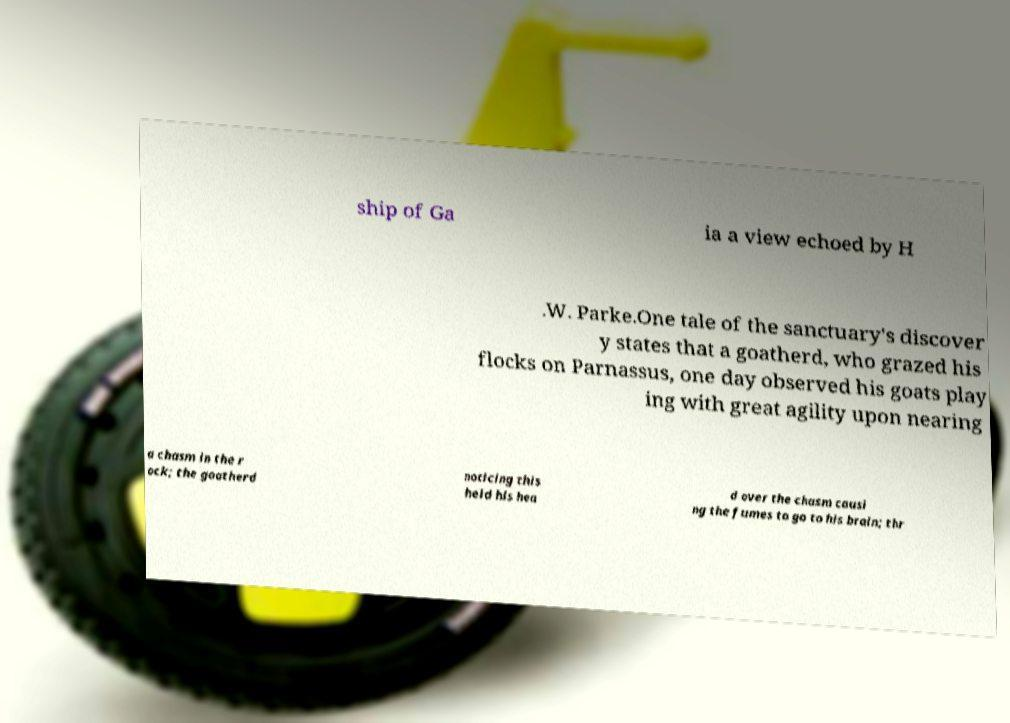For documentation purposes, I need the text within this image transcribed. Could you provide that? ship of Ga ia a view echoed by H .W. Parke.One tale of the sanctuary's discover y states that a goatherd, who grazed his flocks on Parnassus, one day observed his goats play ing with great agility upon nearing a chasm in the r ock; the goatherd noticing this held his hea d over the chasm causi ng the fumes to go to his brain; thr 